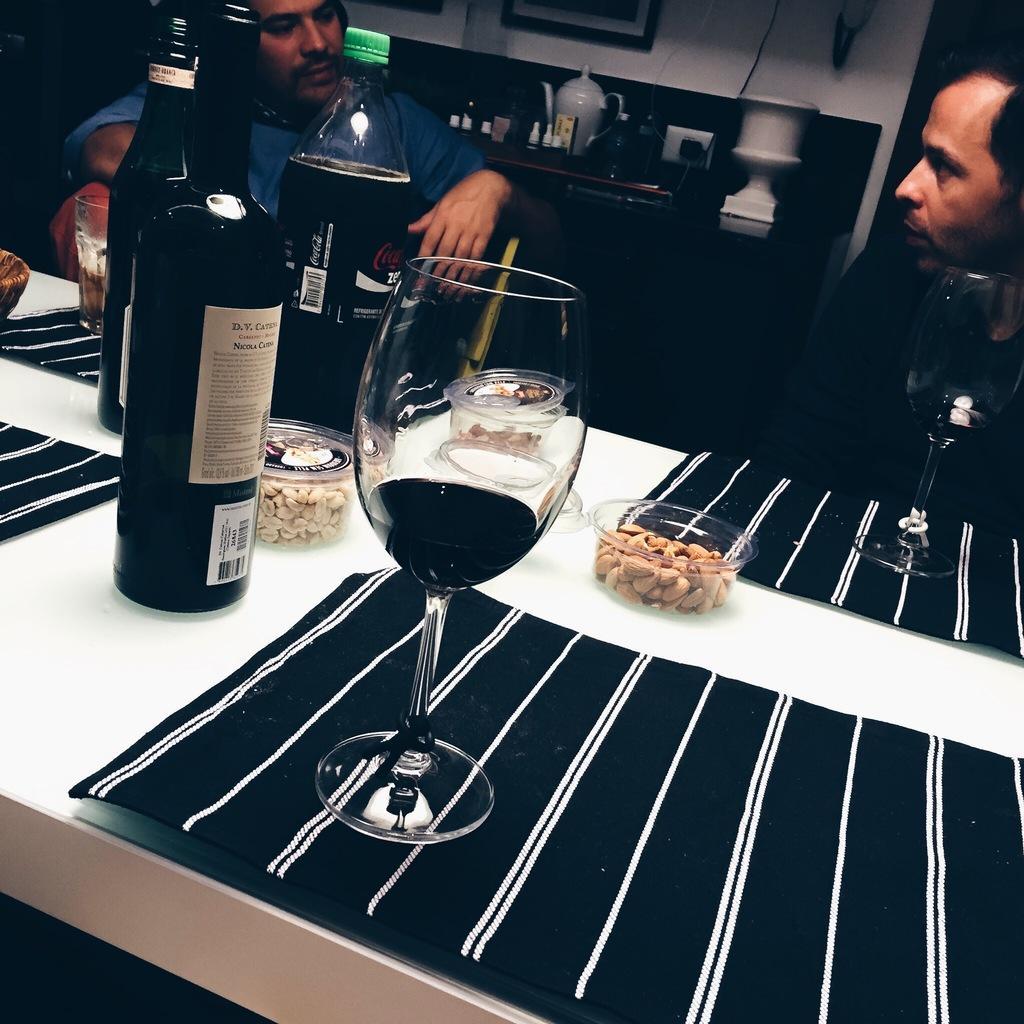In one or two sentences, can you explain what this image depicts? On the background we can see a wall and photo frames over a wall. this is a platform and on the platform we can see a jar and bottles. here we can see two men sitting on chairs in front of a table an don on the table we can see dry fruits boxes, bottles and a glass of drinks and table mats. 